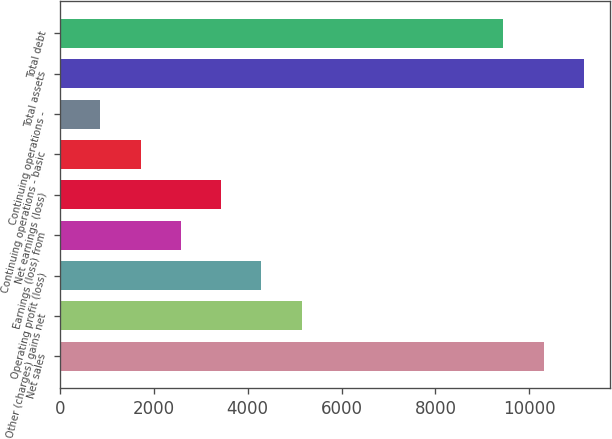<chart> <loc_0><loc_0><loc_500><loc_500><bar_chart><fcel>Net sales<fcel>Other (charges) gains net<fcel>Operating profit (loss)<fcel>Earnings (loss) from<fcel>Net earnings (loss)<fcel>Continuing operations - basic<fcel>Continuing operations -<fcel>Total assets<fcel>Total debt<nl><fcel>10303<fcel>5152.08<fcel>4293.59<fcel>2576.61<fcel>3435.1<fcel>1718.12<fcel>859.64<fcel>11161.5<fcel>9444.52<nl></chart> 